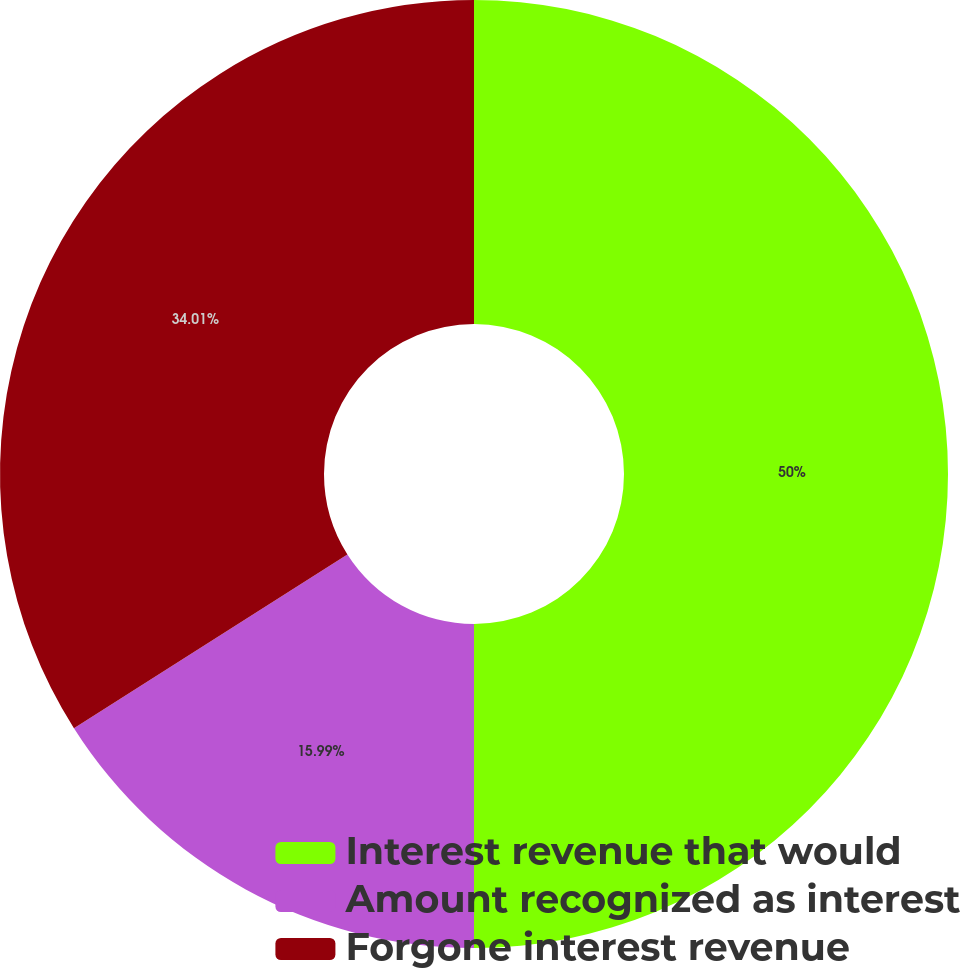Convert chart to OTSL. <chart><loc_0><loc_0><loc_500><loc_500><pie_chart><fcel>Interest revenue that would<fcel>Amount recognized as interest<fcel>Forgone interest revenue<nl><fcel>50.0%<fcel>15.99%<fcel>34.01%<nl></chart> 